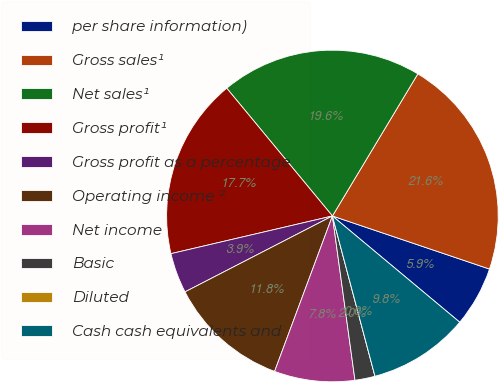Convert chart. <chart><loc_0><loc_0><loc_500><loc_500><pie_chart><fcel>per share information)<fcel>Gross sales¹<fcel>Net sales¹<fcel>Gross profit¹<fcel>Gross profit as a percentage<fcel>Operating income ²<fcel>Net income<fcel>Basic<fcel>Diluted<fcel>Cash cash equivalents and<nl><fcel>5.88%<fcel>21.57%<fcel>19.61%<fcel>17.65%<fcel>3.92%<fcel>11.76%<fcel>7.84%<fcel>1.96%<fcel>0.0%<fcel>9.8%<nl></chart> 